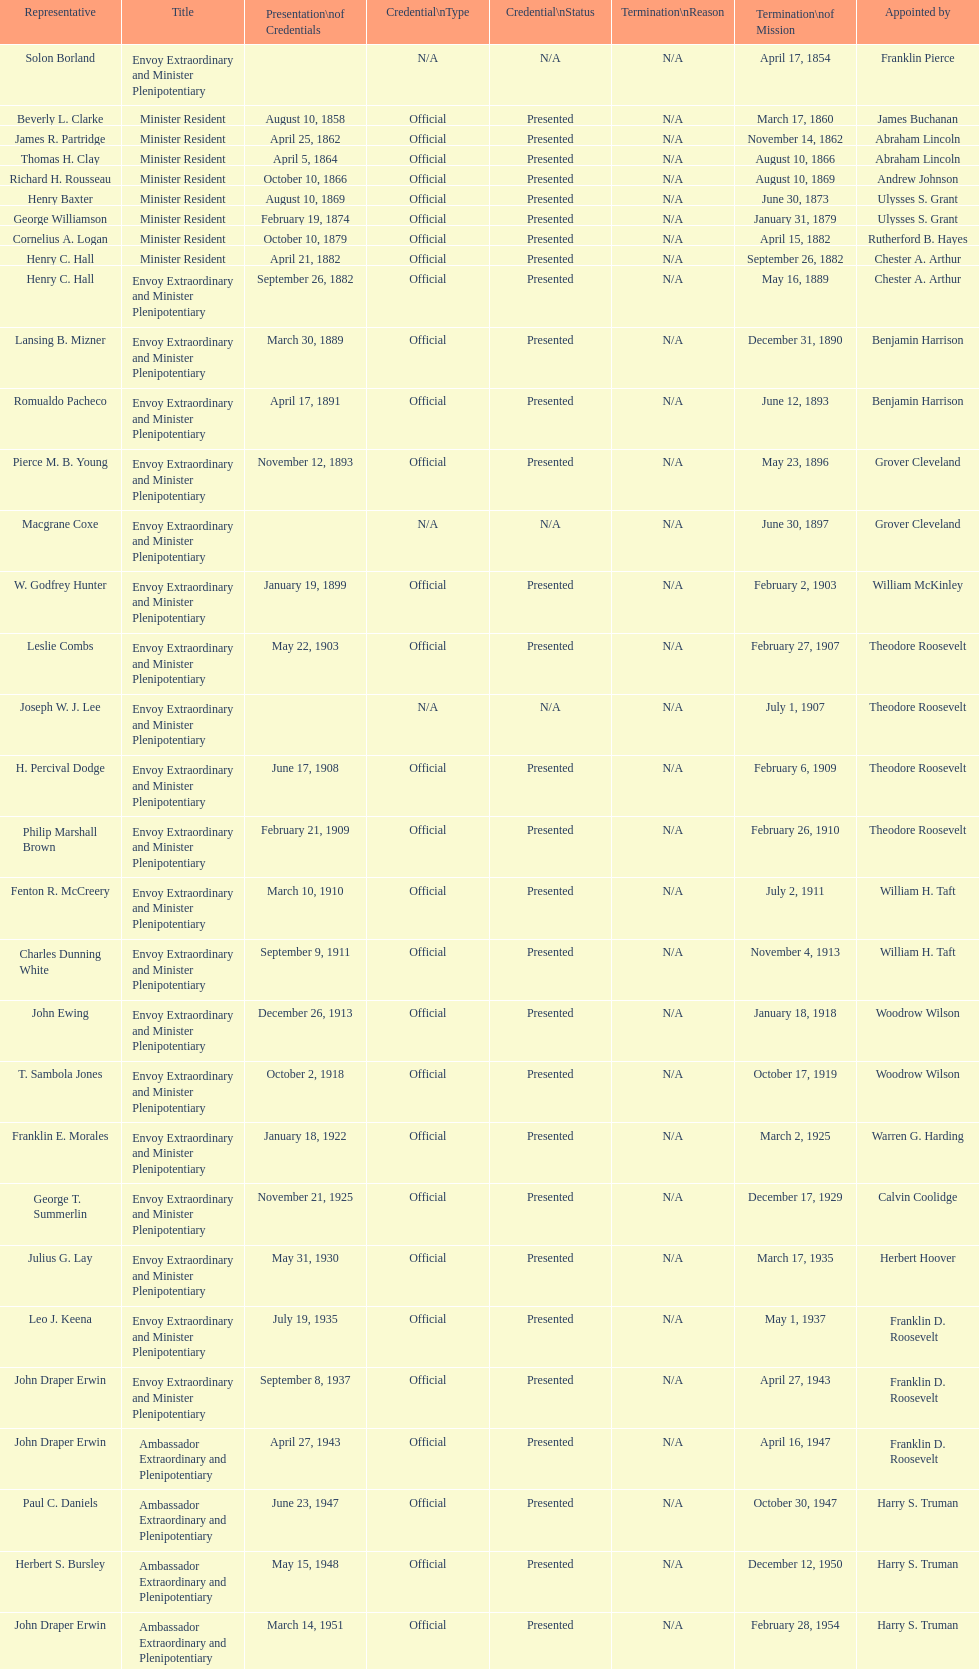What was the length, in years, of leslie combs' term? 4 years. Could you parse the entire table as a dict? {'header': ['Representative', 'Title', 'Presentation\\nof Credentials', 'Credential\\nType', 'Credential\\nStatus', 'Termination\\nReason', 'Termination\\nof Mission', 'Appointed by'], 'rows': [['Solon Borland', 'Envoy Extraordinary and Minister Plenipotentiary', '', 'N/A', 'N/A', 'N/A', 'April 17, 1854', 'Franklin Pierce'], ['Beverly L. Clarke', 'Minister Resident', 'August 10, 1858', 'Official', 'Presented', 'N/A', 'March 17, 1860', 'James Buchanan'], ['James R. Partridge', 'Minister Resident', 'April 25, 1862', 'Official', 'Presented', 'N/A', 'November 14, 1862', 'Abraham Lincoln'], ['Thomas H. Clay', 'Minister Resident', 'April 5, 1864', 'Official', 'Presented', 'N/A', 'August 10, 1866', 'Abraham Lincoln'], ['Richard H. Rousseau', 'Minister Resident', 'October 10, 1866', 'Official', 'Presented', 'N/A', 'August 10, 1869', 'Andrew Johnson'], ['Henry Baxter', 'Minister Resident', 'August 10, 1869', 'Official', 'Presented', 'N/A', 'June 30, 1873', 'Ulysses S. Grant'], ['George Williamson', 'Minister Resident', 'February 19, 1874', 'Official', 'Presented', 'N/A', 'January 31, 1879', 'Ulysses S. Grant'], ['Cornelius A. Logan', 'Minister Resident', 'October 10, 1879', 'Official', 'Presented', 'N/A', 'April 15, 1882', 'Rutherford B. Hayes'], ['Henry C. Hall', 'Minister Resident', 'April 21, 1882', 'Official', 'Presented', 'N/A', 'September 26, 1882', 'Chester A. Arthur'], ['Henry C. Hall', 'Envoy Extraordinary and Minister Plenipotentiary', 'September 26, 1882', 'Official', 'Presented', 'N/A', 'May 16, 1889', 'Chester A. Arthur'], ['Lansing B. Mizner', 'Envoy Extraordinary and Minister Plenipotentiary', 'March 30, 1889', 'Official', 'Presented', 'N/A', 'December 31, 1890', 'Benjamin Harrison'], ['Romualdo Pacheco', 'Envoy Extraordinary and Minister Plenipotentiary', 'April 17, 1891', 'Official', 'Presented', 'N/A', 'June 12, 1893', 'Benjamin Harrison'], ['Pierce M. B. Young', 'Envoy Extraordinary and Minister Plenipotentiary', 'November 12, 1893', 'Official', 'Presented', 'N/A', 'May 23, 1896', 'Grover Cleveland'], ['Macgrane Coxe', 'Envoy Extraordinary and Minister Plenipotentiary', '', 'N/A', 'N/A', 'N/A', 'June 30, 1897', 'Grover Cleveland'], ['W. Godfrey Hunter', 'Envoy Extraordinary and Minister Plenipotentiary', 'January 19, 1899', 'Official', 'Presented', 'N/A', 'February 2, 1903', 'William McKinley'], ['Leslie Combs', 'Envoy Extraordinary and Minister Plenipotentiary', 'May 22, 1903', 'Official', 'Presented', 'N/A', 'February 27, 1907', 'Theodore Roosevelt'], ['Joseph W. J. Lee', 'Envoy Extraordinary and Minister Plenipotentiary', '', 'N/A', 'N/A', 'N/A', 'July 1, 1907', 'Theodore Roosevelt'], ['H. Percival Dodge', 'Envoy Extraordinary and Minister Plenipotentiary', 'June 17, 1908', 'Official', 'Presented', 'N/A', 'February 6, 1909', 'Theodore Roosevelt'], ['Philip Marshall Brown', 'Envoy Extraordinary and Minister Plenipotentiary', 'February 21, 1909', 'Official', 'Presented', 'N/A', 'February 26, 1910', 'Theodore Roosevelt'], ['Fenton R. McCreery', 'Envoy Extraordinary and Minister Plenipotentiary', 'March 10, 1910', 'Official', 'Presented', 'N/A', 'July 2, 1911', 'William H. Taft'], ['Charles Dunning White', 'Envoy Extraordinary and Minister Plenipotentiary', 'September 9, 1911', 'Official', 'Presented', 'N/A', 'November 4, 1913', 'William H. Taft'], ['John Ewing', 'Envoy Extraordinary and Minister Plenipotentiary', 'December 26, 1913', 'Official', 'Presented', 'N/A', 'January 18, 1918', 'Woodrow Wilson'], ['T. Sambola Jones', 'Envoy Extraordinary and Minister Plenipotentiary', 'October 2, 1918', 'Official', 'Presented', 'N/A', 'October 17, 1919', 'Woodrow Wilson'], ['Franklin E. Morales', 'Envoy Extraordinary and Minister Plenipotentiary', 'January 18, 1922', 'Official', 'Presented', 'N/A', 'March 2, 1925', 'Warren G. Harding'], ['George T. Summerlin', 'Envoy Extraordinary and Minister Plenipotentiary', 'November 21, 1925', 'Official', 'Presented', 'N/A', 'December 17, 1929', 'Calvin Coolidge'], ['Julius G. Lay', 'Envoy Extraordinary and Minister Plenipotentiary', 'May 31, 1930', 'Official', 'Presented', 'N/A', 'March 17, 1935', 'Herbert Hoover'], ['Leo J. Keena', 'Envoy Extraordinary and Minister Plenipotentiary', 'July 19, 1935', 'Official', 'Presented', 'N/A', 'May 1, 1937', 'Franklin D. Roosevelt'], ['John Draper Erwin', 'Envoy Extraordinary and Minister Plenipotentiary', 'September 8, 1937', 'Official', 'Presented', 'N/A', 'April 27, 1943', 'Franklin D. Roosevelt'], ['John Draper Erwin', 'Ambassador Extraordinary and Plenipotentiary', 'April 27, 1943', 'Official', 'Presented', 'N/A', 'April 16, 1947', 'Franklin D. Roosevelt'], ['Paul C. Daniels', 'Ambassador Extraordinary and Plenipotentiary', 'June 23, 1947', 'Official', 'Presented', 'N/A', 'October 30, 1947', 'Harry S. Truman'], ['Herbert S. Bursley', 'Ambassador Extraordinary and Plenipotentiary', 'May 15, 1948', 'Official', 'Presented', 'N/A', 'December 12, 1950', 'Harry S. Truman'], ['John Draper Erwin', 'Ambassador Extraordinary and Plenipotentiary', 'March 14, 1951', 'Official', 'Presented', 'N/A', 'February 28, 1954', 'Harry S. Truman'], ['Whiting Willauer', 'Ambassador Extraordinary and Plenipotentiary', 'March 5, 1954', 'Official', 'Presented', 'N/A', 'March 24, 1958', 'Dwight D. Eisenhower'], ['Robert Newbegin', 'Ambassador Extraordinary and Plenipotentiary', 'April 30, 1958', 'Official', 'Presented', 'N/A', 'August 3, 1960', 'Dwight D. Eisenhower'], ['Charles R. Burrows', 'Ambassador Extraordinary and Plenipotentiary', 'November 3, 1960', 'Official', 'Presented', 'N/A', 'June 28, 1965', 'Dwight D. Eisenhower'], ['Joseph J. Jova', 'Ambassador Extraordinary and Plenipotentiary', 'July 12, 1965', 'Official', 'Presented', 'N/A', 'June 21, 1969', 'Lyndon B. Johnson'], ['Hewson A. Ryan', 'Ambassador Extraordinary and Plenipotentiary', 'November 5, 1969', 'Official', 'Presented', 'N/A', 'May 30, 1973', 'Richard Nixon'], ['Phillip V. Sanchez', 'Ambassador Extraordinary and Plenipotentiary', 'June 15, 1973', 'Official', 'Presented', 'N/A', 'July 17, 1976', 'Richard Nixon'], ['Ralph E. Becker', 'Ambassador Extraordinary and Plenipotentiary', 'October 27, 1976', 'Official', 'Presented', 'N/A', 'August 1, 1977', 'Gerald Ford'], ['Mari-Luci Jaramillo', 'Ambassador Extraordinary and Plenipotentiary', 'October 27, 1977', 'Official', 'Presented', 'N/A', 'September 19, 1980', 'Jimmy Carter'], ['Jack R. Binns', 'Ambassador Extraordinary and Plenipotentiary', 'October 10, 1980', 'Official', 'Presented', 'N/A', 'October 31, 1981', 'Jimmy Carter'], ['John D. Negroponte', 'Ambassador Extraordinary and Plenipotentiary', 'November 11, 1981', 'Official', 'Presented', 'N/A', 'May 30, 1985', 'Ronald Reagan'], ['John Arthur Ferch', 'Ambassador Extraordinary and Plenipotentiary', 'August 22, 1985', 'Official', 'Presented', 'N/A', 'July 9, 1986', 'Ronald Reagan'], ['Everett Ellis Briggs', 'Ambassador Extraordinary and Plenipotentiary', 'November 4, 1986', 'Official', 'Presented', 'N/A', 'June 15, 1989', 'Ronald Reagan'], ['Cresencio S. Arcos, Jr.', 'Ambassador Extraordinary and Plenipotentiary', 'January 29, 1990', 'Official', 'Presented', 'N/A', 'July 1, 1993', 'George H. W. Bush'], ['William Thornton Pryce', 'Ambassador Extraordinary and Plenipotentiary', 'July 21, 1993', 'Official', 'Presented', 'N/A', 'August 15, 1996', 'Bill Clinton'], ['James F. Creagan', 'Ambassador Extraordinary and Plenipotentiary', 'August 29, 1996', 'Official', 'Presented', 'N/A', 'July 20, 1999', 'Bill Clinton'], ['Frank Almaguer', 'Ambassador Extraordinary and Plenipotentiary', 'August 25, 1999', 'Official', 'Presented', 'N/A', 'September 5, 2002', 'Bill Clinton'], ['Larry Leon Palmer', 'Ambassador Extraordinary and Plenipotentiary', 'October 8, 2002', 'Official', 'Presented', 'N/A', 'May 7, 2005', 'George W. Bush'], ['Charles A. Ford', 'Ambassador Extraordinary and Plenipotentiary', 'November 8, 2005', 'Official', 'Presented', 'N/A', 'ca. April 2008', 'George W. Bush'], ['Hugo Llorens', 'Ambassador Extraordinary and Plenipotentiary', 'September 19, 2008', 'Official', 'Presented', 'N/A', 'ca. July 2011', 'George W. Bush'], ['Lisa Kubiske', 'Ambassador Extraordinary and Plenipotentiary', 'July 26, 2011', 'Official', 'Presented', 'Incumbent', 'Incumbent', 'Barack Obama']]} 